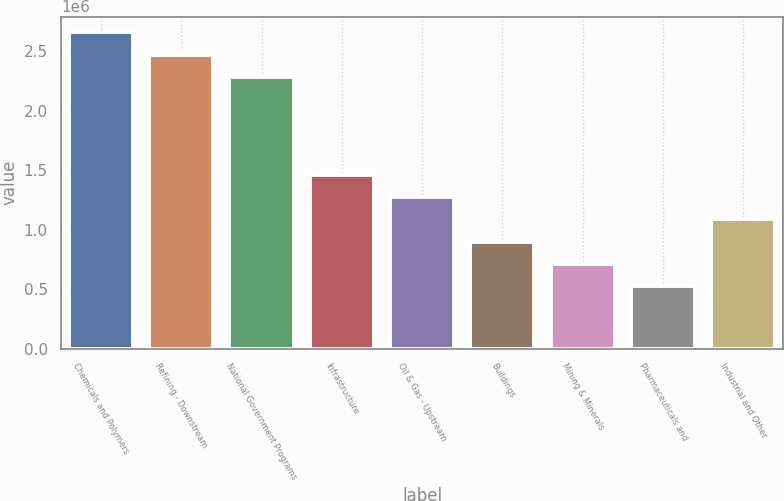Convert chart to OTSL. <chart><loc_0><loc_0><loc_500><loc_500><bar_chart><fcel>Chemicals and Polymers<fcel>Refining - Downstream<fcel>National Government Programs<fcel>Infrastructure<fcel>Oil & Gas - Upstream<fcel>Buildings<fcel>Mining & Minerals<fcel>Pharmaceuticals and<fcel>Industrial and Other<nl><fcel>2.65806e+06<fcel>2.4713e+06<fcel>2.28453e+06<fcel>1.45938e+06<fcel>1.27262e+06<fcel>899085<fcel>712320<fcel>523490<fcel>1.08585e+06<nl></chart> 